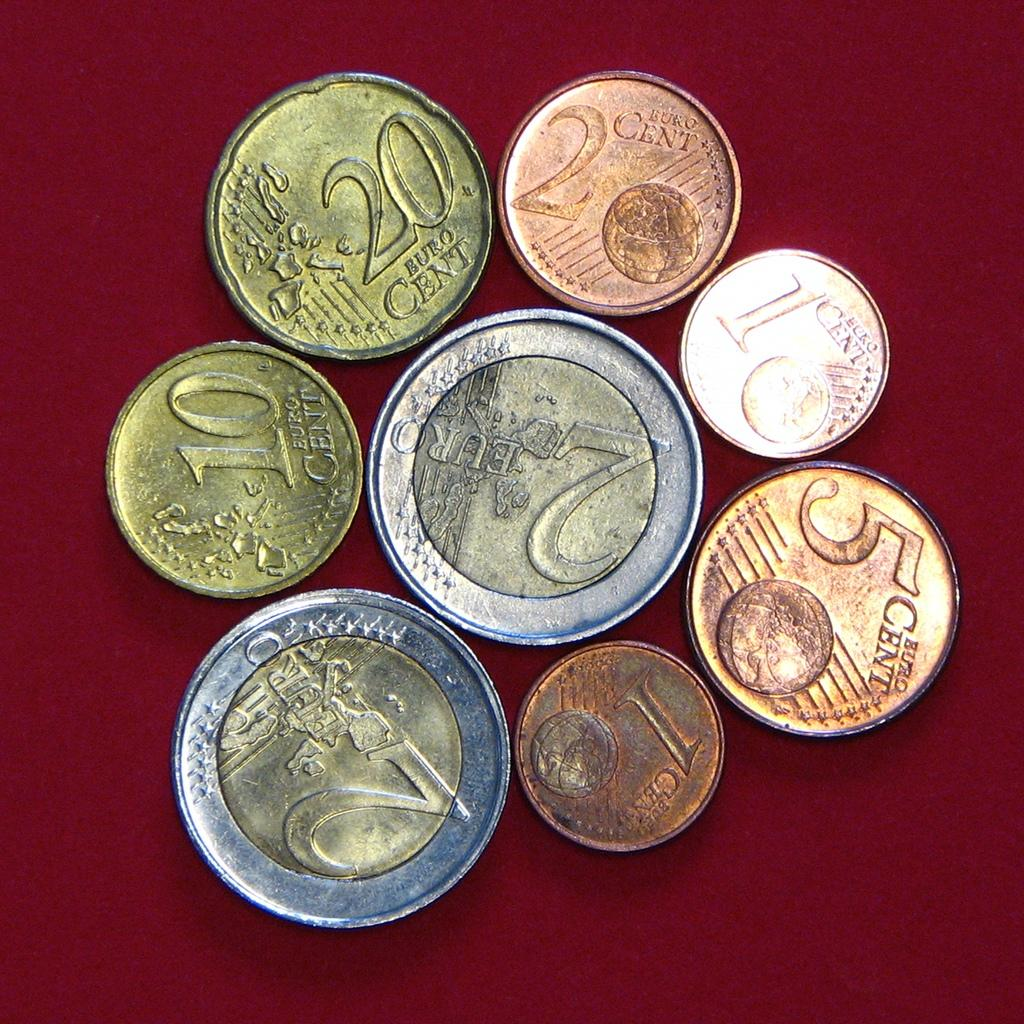<image>
Summarize the visual content of the image. A range of Euro coins from 2 cents to 2 euros. 